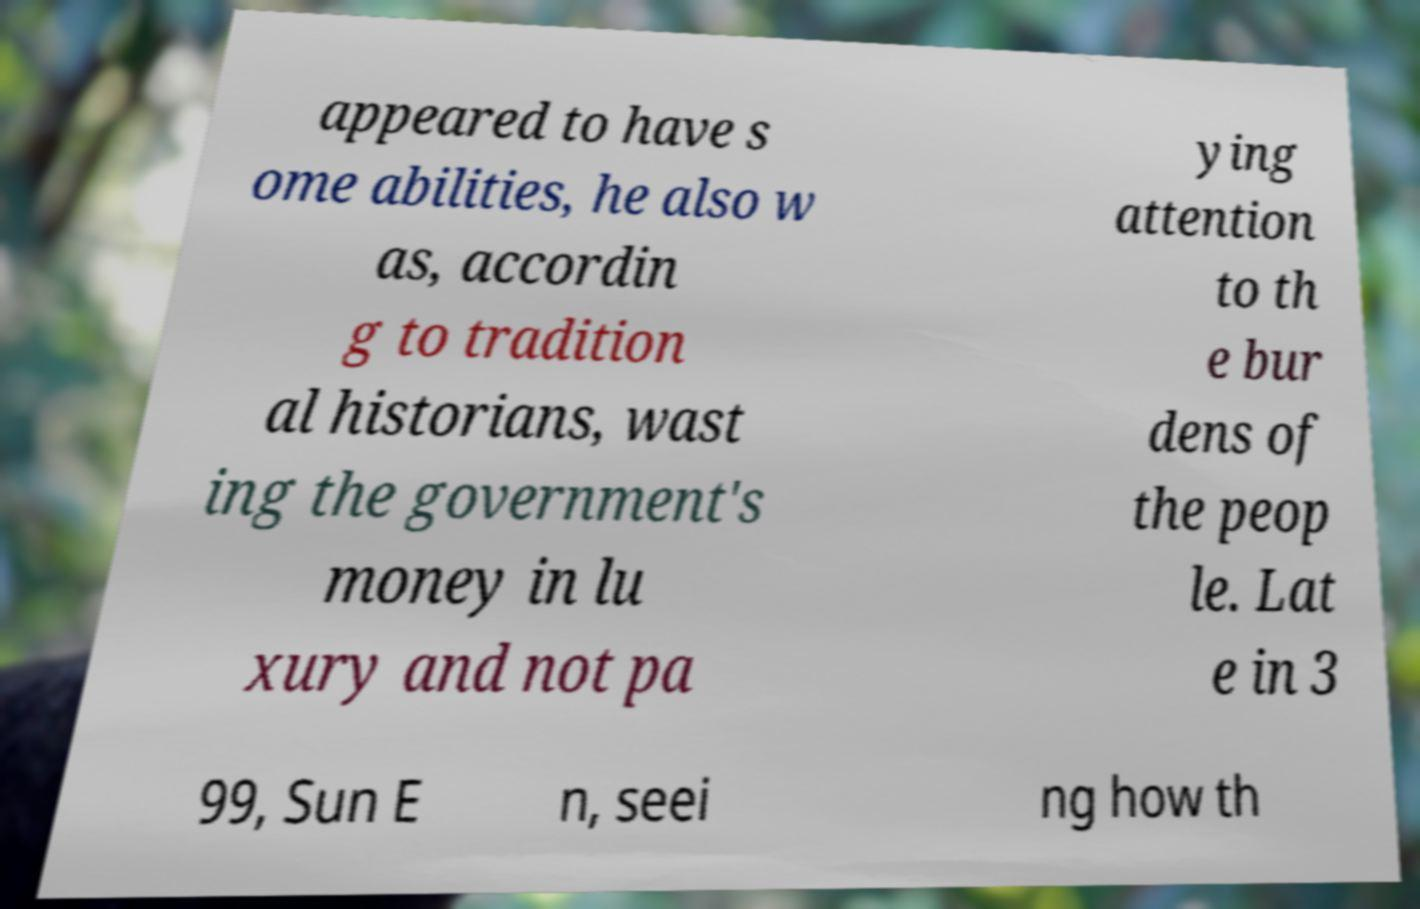Please identify and transcribe the text found in this image. appeared to have s ome abilities, he also w as, accordin g to tradition al historians, wast ing the government's money in lu xury and not pa ying attention to th e bur dens of the peop le. Lat e in 3 99, Sun E n, seei ng how th 